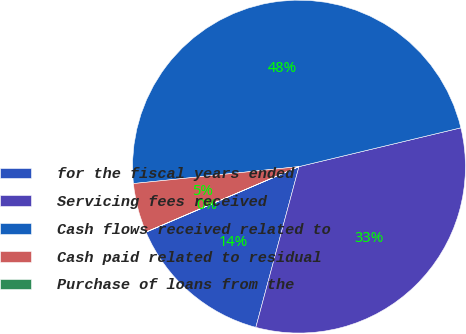<chart> <loc_0><loc_0><loc_500><loc_500><pie_chart><fcel>for the fiscal years ended<fcel>Servicing fees received<fcel>Cash flows received related to<fcel>Cash paid related to residual<fcel>Purchase of loans from the<nl><fcel>14.38%<fcel>32.92%<fcel>47.88%<fcel>4.8%<fcel>0.02%<nl></chart> 